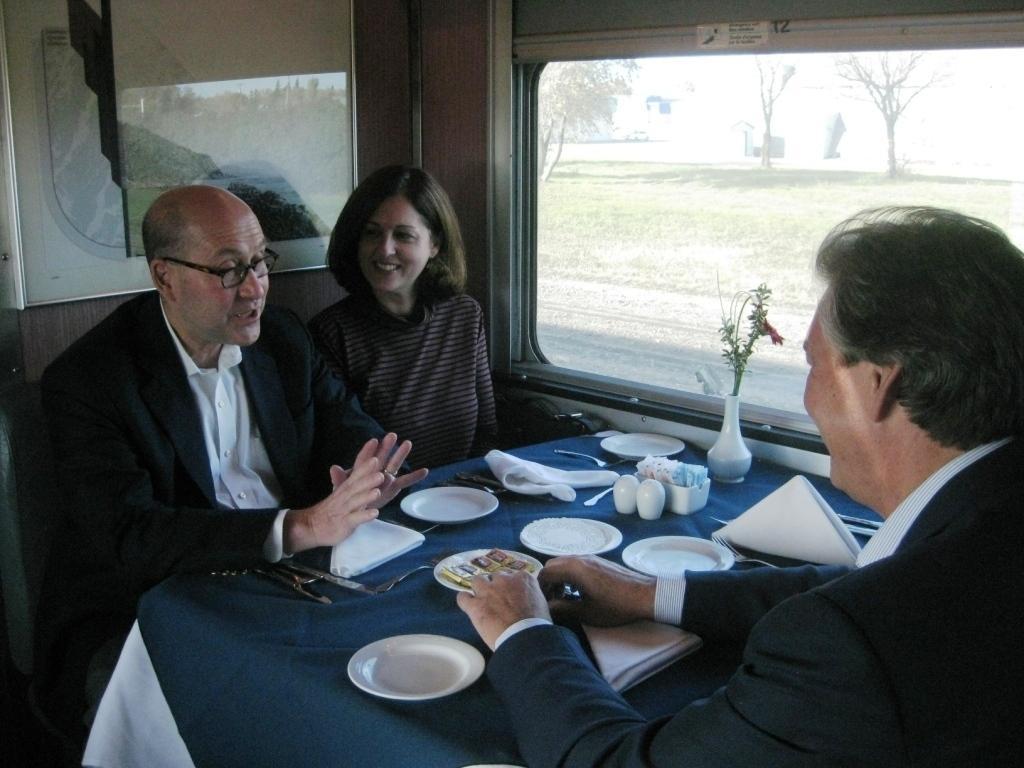Describe this image in one or two sentences. In this image, we can see persons wearing clothes and sitting in front of the table beside the window. This table contains plates, tissues and flower vase. 